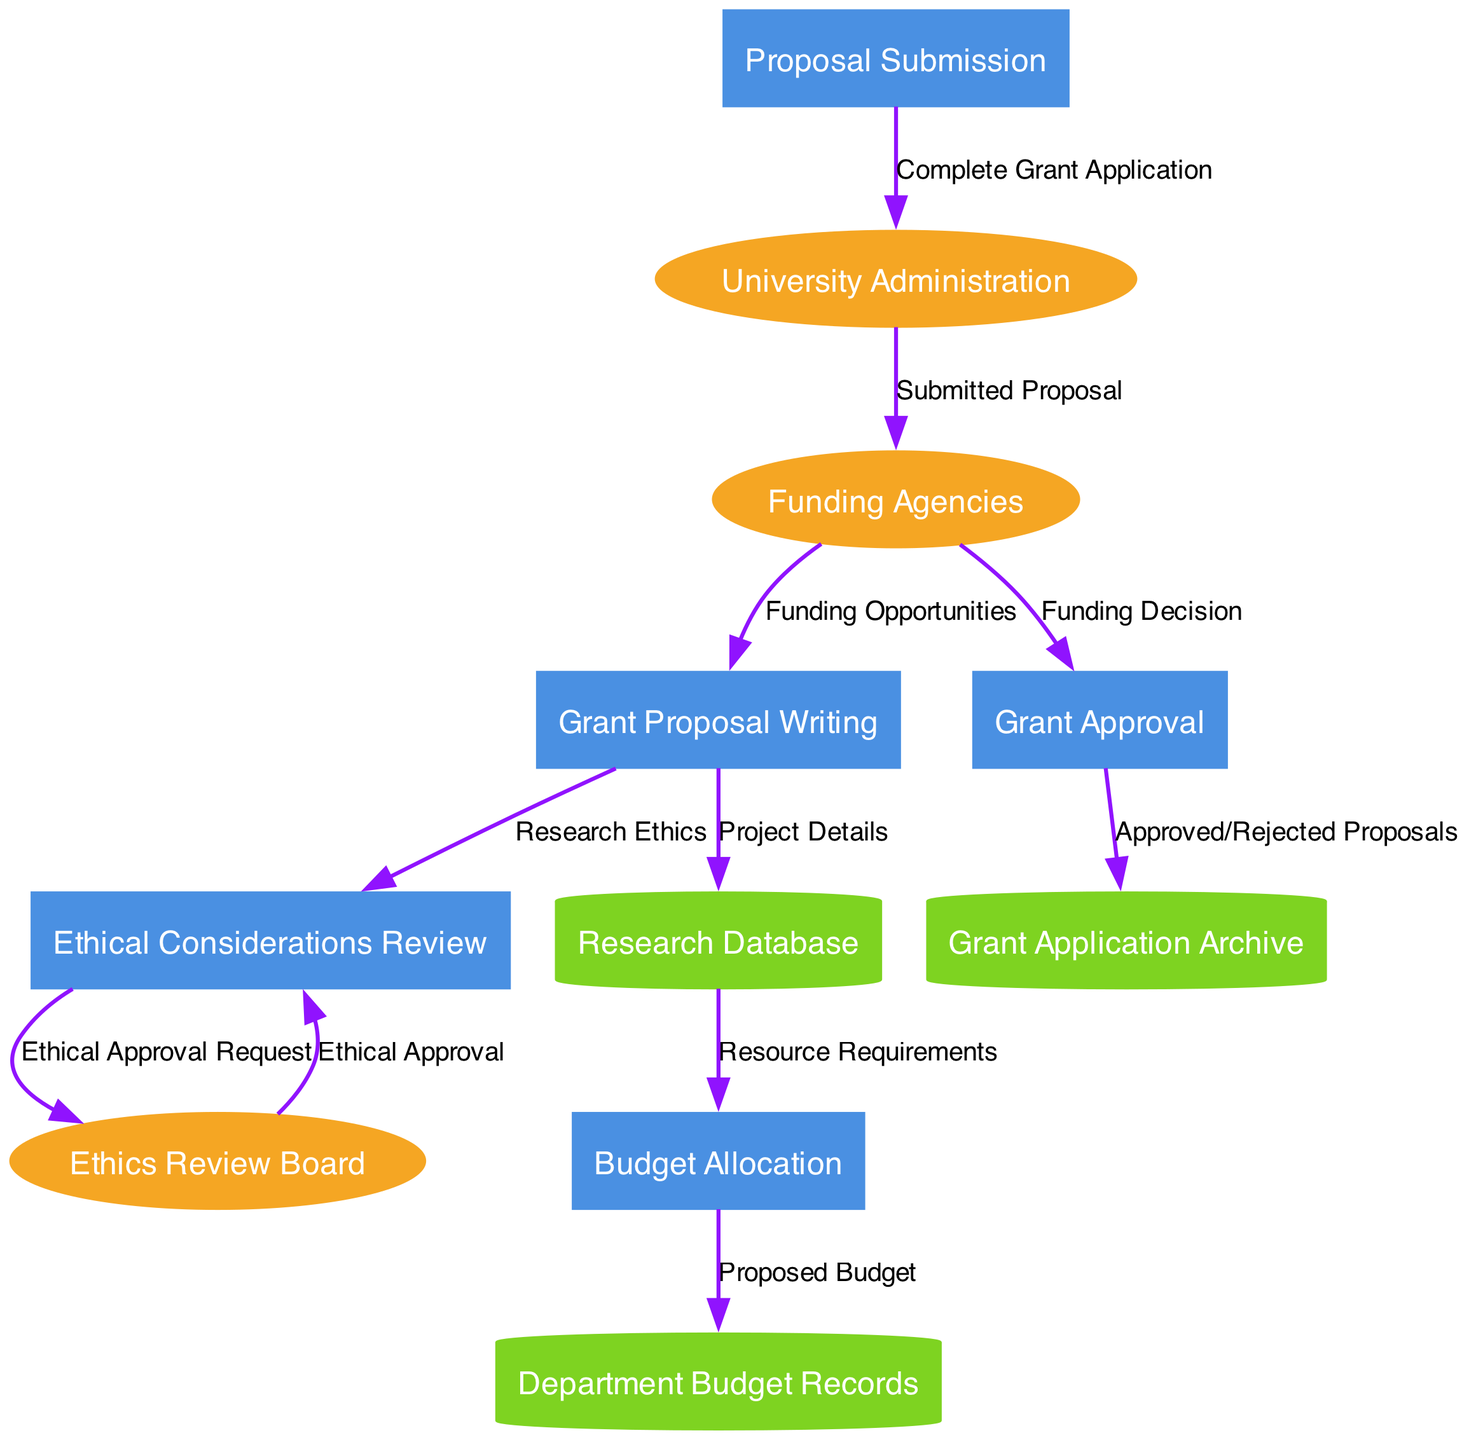What are the external entities in the diagram? The external entities are identified at the top of the diagram, which are Funding Agencies, Ethics Review Board, and University Administration. These are the main sources or stakeholders that interact with the processes in the philosophy department’s grant application process.
Answer: Funding Agencies, Ethics Review Board, University Administration How many processes are shown in the diagram? The processes are represented by the rectangles within the diagram. Counting these, there are five distinct processes: Grant Proposal Writing, Budget Allocation, Ethical Considerations Review, Proposal Submission, and Grant Approval.
Answer: 5 What is the data flow from "Grant Proposal Writing" to "Research Database"? The data flow from "Grant Proposal Writing" to "Research Database" is labeled as "Project Details." This denotes that specific project-related information is transferred from the process of writing the grant proposal to the research database for storage or reference.
Answer: Project Details Which data store receives flows from the "Budget Allocation"? The data store that receives flows from "Budget Allocation" is the "Department Budget Records." This indicates that the proposed budget stemming from the budget allocation process is stored in that data store.
Answer: Department Budget Records What flow of data occurs between the "Ethical Considerations Review" and "Ethics Review Board"? The flow of data between "Ethical Considerations Review" and "Ethics Review Board" is an "Ethical Approval Request." This signifies that the review process submits a request for ethical approval to the ethics board, which is a crucial part of ensuring the research complies with ethical standards.
Answer: Ethical Approval Request What is the final destination of the data flow labeled "Submitted Proposal"? The final destination of the data flow labeled "Submitted Proposal" is "Funding Agencies." This indicates that the completed grant application is sent to the funding agencies for their consideration in the grant approval process.
Answer: Funding Agencies How many data stores are present in the diagram? There are three data stores present in the diagram: Research Database, Department Budget Records, and Grant Application Archive. This shows the various locations where data is stored throughout the grant application process.
Answer: 3 What is the data flow from "Grant Approval" to "Grant Application Archive"? The data flow from "Grant Approval" to "Grant Application Archive" is labeled as "Approved/Rejected Proposals." This indicates that the outcomes of the grant approval process are documented in the grant application archive, reflecting whether the proposals were approved or rejected.
Answer: Approved/Rejected Proposals What does "Funding Decision" signify in the context of the diagram? "Funding Decision" signifies the point of evaluation by the funding agencies after the proposal is submitted. It indicates the outcome that determines whether the grant proposal has been approved or rejected, influencing the project’s direction and funding status.
Answer: Funding Decision What is the process that directly precedes "Proposal Submission"? The process directly preceding "Proposal Submission" in the flow is "Ethical Considerations Review." This means that ethical aspects of the proposal need to be reviewed and approved before submitting the grant application to the university administration.
Answer: Ethical Considerations Review 